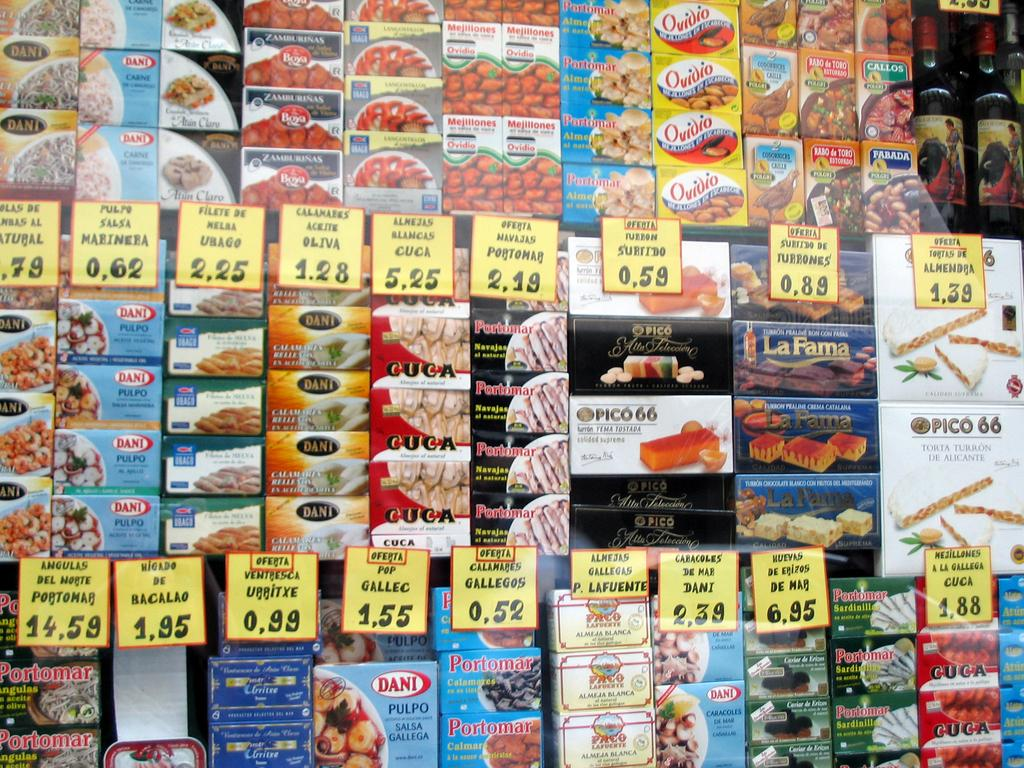<image>
Share a concise interpretation of the image provided. shelves of groceries including pulpo salsa marinera for 0,62 and almejas blancas cuca for 5,25 